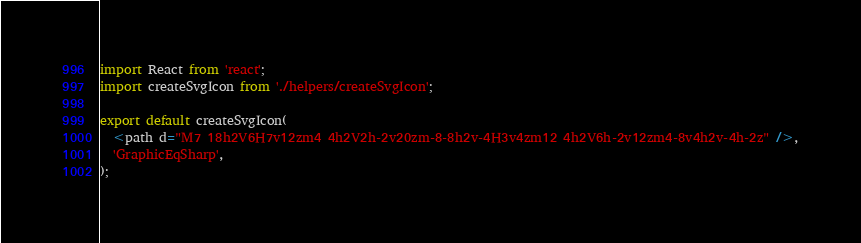<code> <loc_0><loc_0><loc_500><loc_500><_TypeScript_>import React from 'react';
import createSvgIcon from './helpers/createSvgIcon';

export default createSvgIcon(
  <path d="M7 18h2V6H7v12zm4 4h2V2h-2v20zm-8-8h2v-4H3v4zm12 4h2V6h-2v12zm4-8v4h2v-4h-2z" />,
  'GraphicEqSharp',
);
</code> 